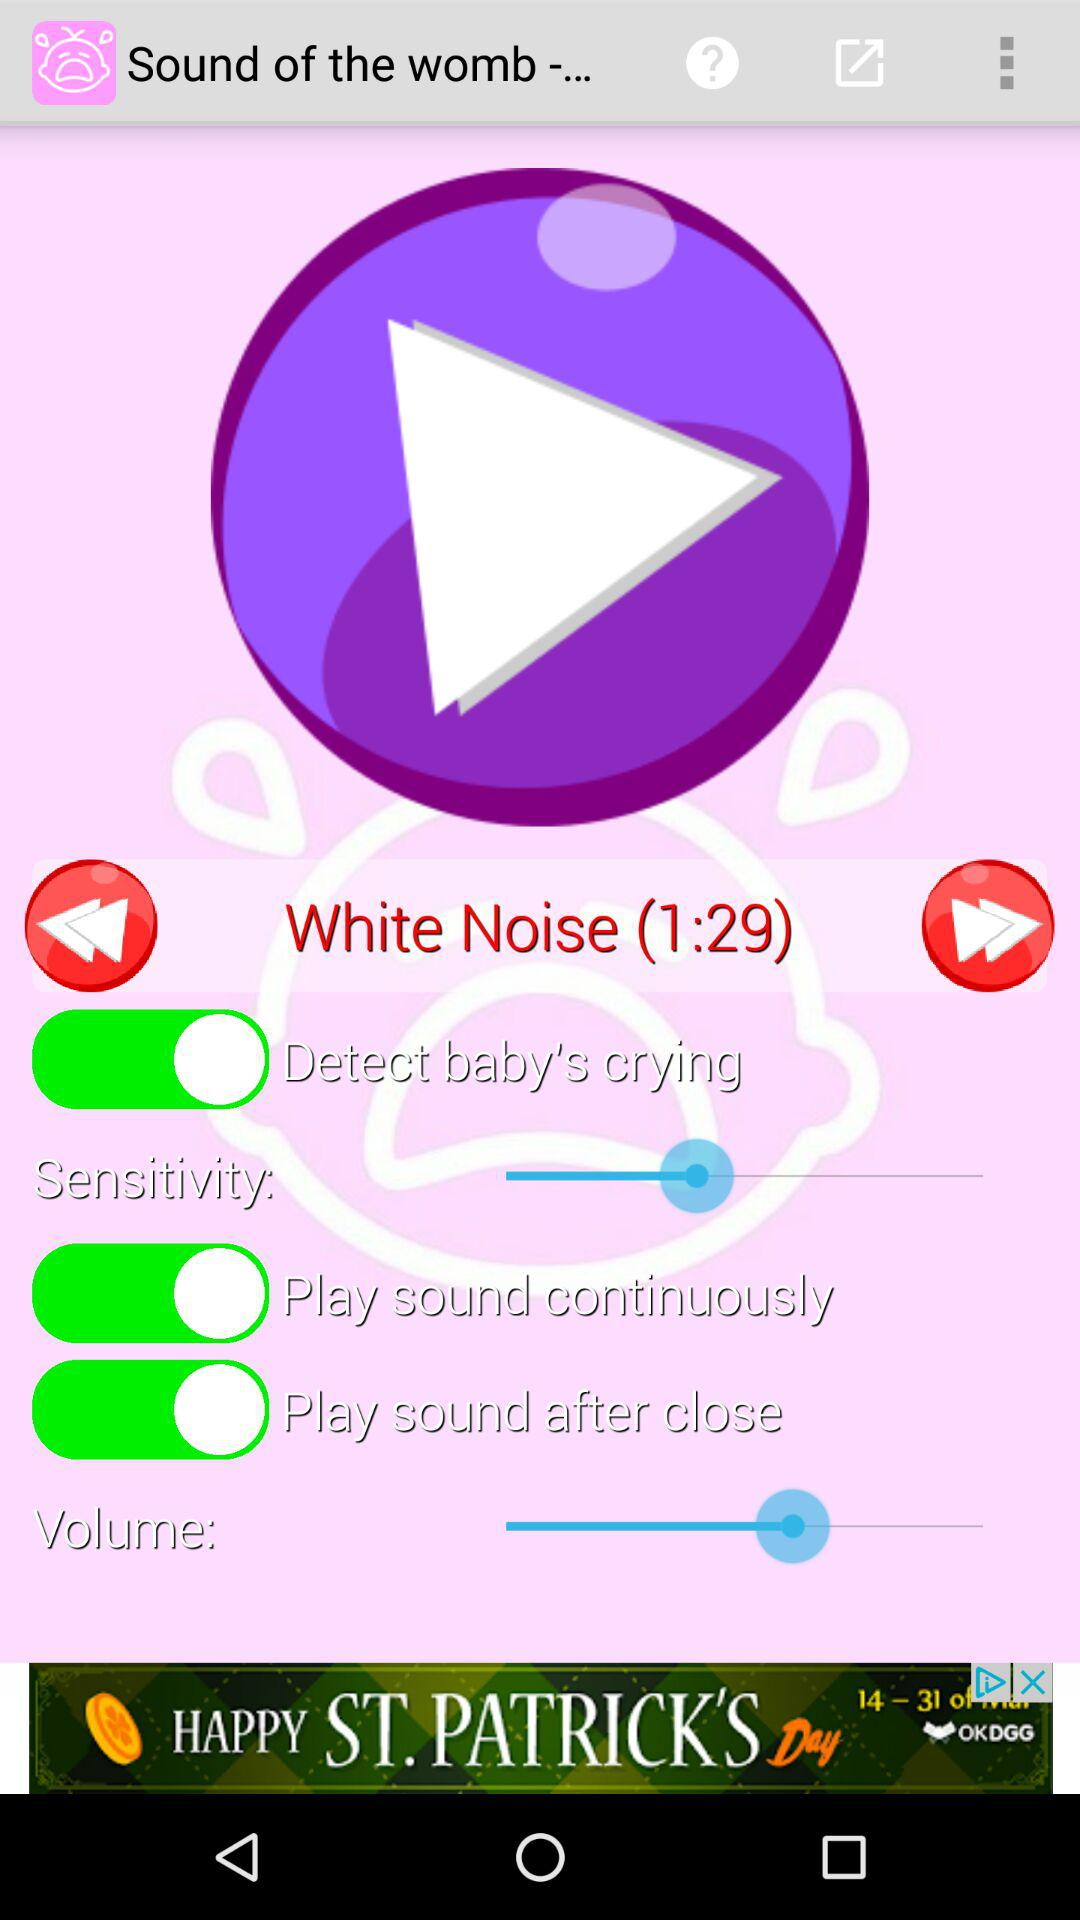What is the current status of "Play sound continuously"? The current status of "Play sound continuously" is "on". 